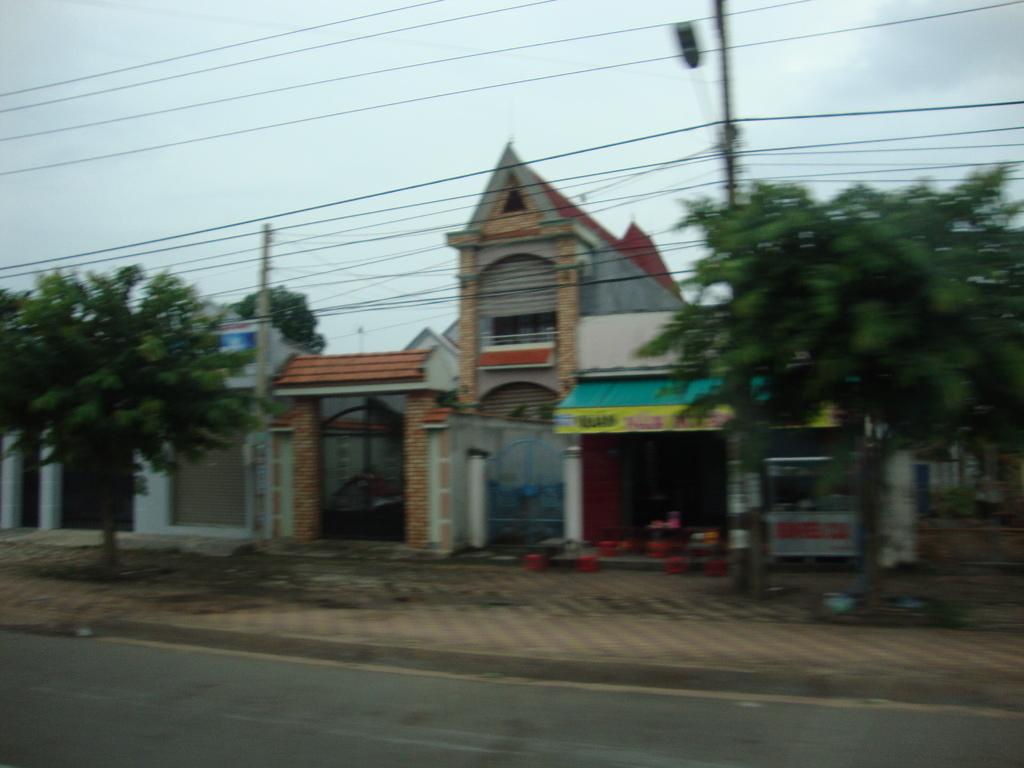What is visible in the center of the image? The sky is visible in the center of the image. What can be seen in the sky? Clouds are present in the image. What structures are visible in the image? Poles, buildings, and a road are visible in the image. What type of vegetation is present in the image? Trees are present in the image. Are there any other objects visible in the image? Yes, there are a few other objects in the image. How long does it take for the knife to make a wish in the image? There is no knife or wishing activity present in the image. 